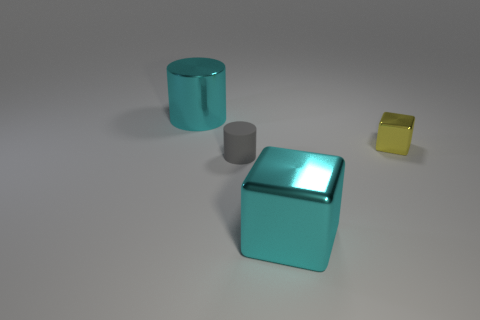Does the cyan cube have the same material as the gray cylinder?
Provide a short and direct response. No. How many objects are tiny brown matte objects or things left of the big metallic block?
Provide a succinct answer. 2. There is a metal cylinder that is the same color as the big block; what size is it?
Offer a very short reply. Large. What shape is the large cyan thing that is in front of the small gray rubber object?
Make the answer very short. Cube. Is the color of the big metallic thing that is behind the small metallic cube the same as the large block?
Provide a succinct answer. Yes. There is a large object that is the same color as the large cylinder; what is its material?
Offer a terse response. Metal. Is the size of the shiny thing on the right side of the cyan cube the same as the small gray thing?
Provide a succinct answer. Yes. Are there any shiny objects of the same color as the big block?
Your response must be concise. Yes. There is a metal thing left of the tiny gray rubber cylinder; are there any blocks to the right of it?
Ensure brevity in your answer.  Yes. Are there any other big objects that have the same material as the yellow thing?
Make the answer very short. Yes. 